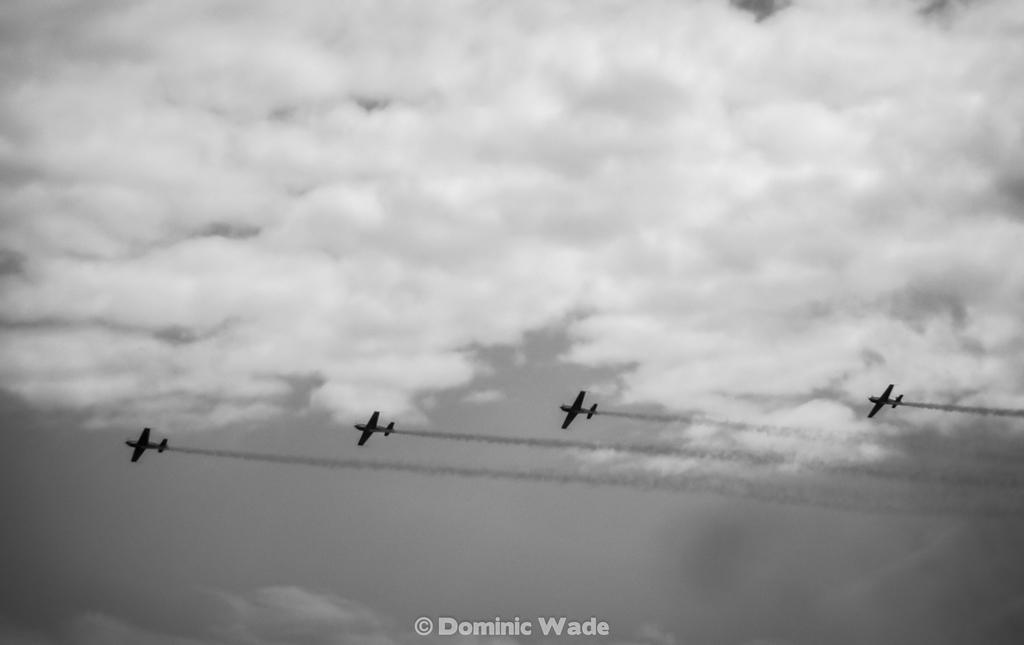How many airplanes are present in the image? There are four airplanes in the sky. Where are the airplanes located in the image? The airplanes are visible at the bottom of the image. What is the condition of the sky in the background? The sky in the background is cloudy. What type of belief is represented by the worm in the image? There is no worm present in the image, so it is not possible to determine any beliefs represented by a worm. 